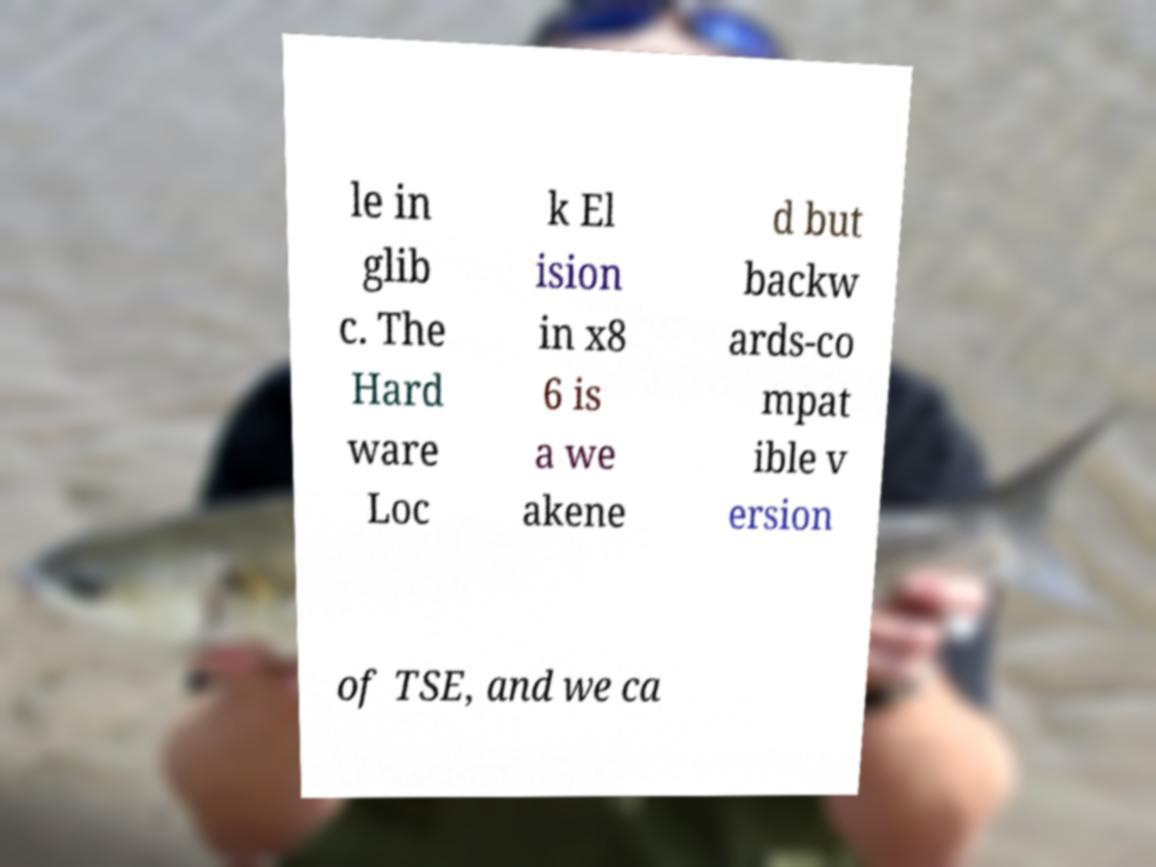I need the written content from this picture converted into text. Can you do that? le in glib c. The Hard ware Loc k El ision in x8 6 is a we akene d but backw ards-co mpat ible v ersion of TSE, and we ca 